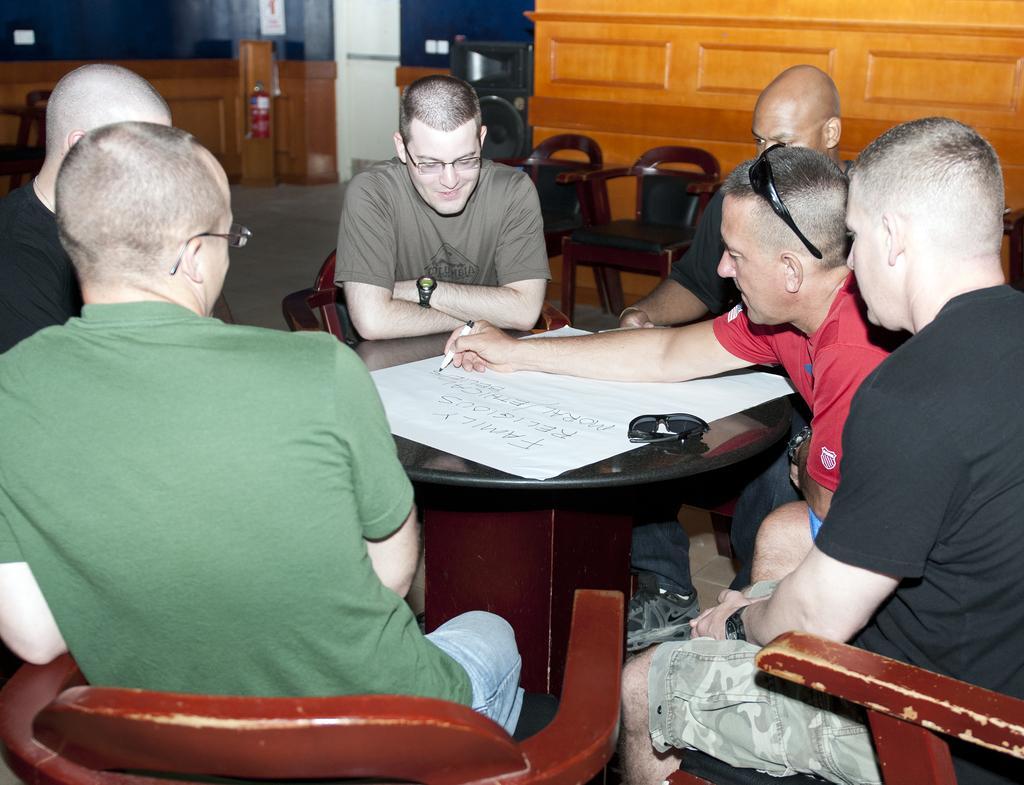Can you describe this image briefly? In this picture there is a man who is holding a pen and writing something on the paper. On the table I can see the goggles and paper. On the right there is a man who is wearing black t-shirt and short. He is sitting on the wooden chair. On the left there is a man who is wearing green t-shirt. He is sitting near to the table, beside him I can see a bald man who is wearing a black t-shirt. In the center there is a man who is smiling, beside him I can see another bald man who is wearing a black t-shirt. In the back I can see the partitions, chairs and other objects. 